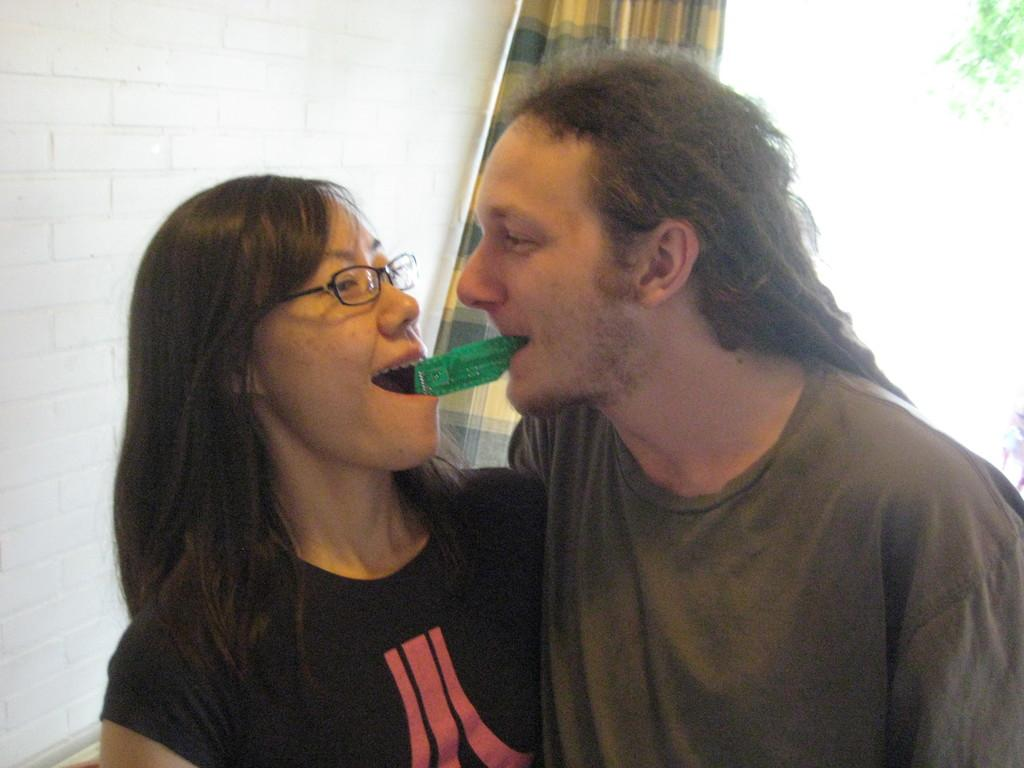How many people are in the image? There are two people in the image. What are the people doing in the image? The people are holding an object in their mouth. What can be seen in the background of the image? There is a curtain and a wall in the background of the image. What type of business is being conducted in the image? There is no indication of any business being conducted in the image. 